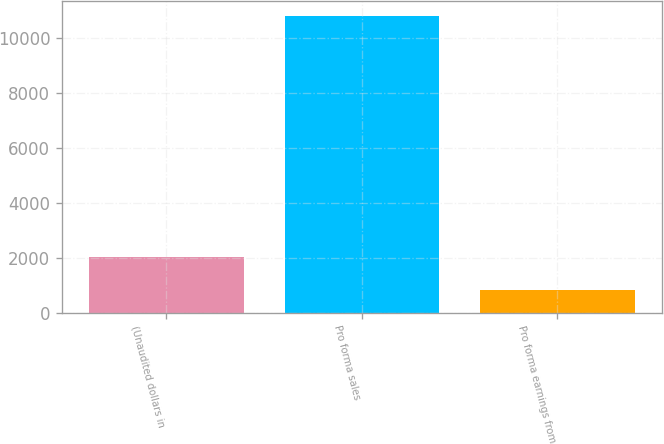Convert chart to OTSL. <chart><loc_0><loc_0><loc_500><loc_500><bar_chart><fcel>(Unaudited dollars in<fcel>Pro forma sales<fcel>Pro forma earnings from<nl><fcel>2014<fcel>10819<fcel>834<nl></chart> 